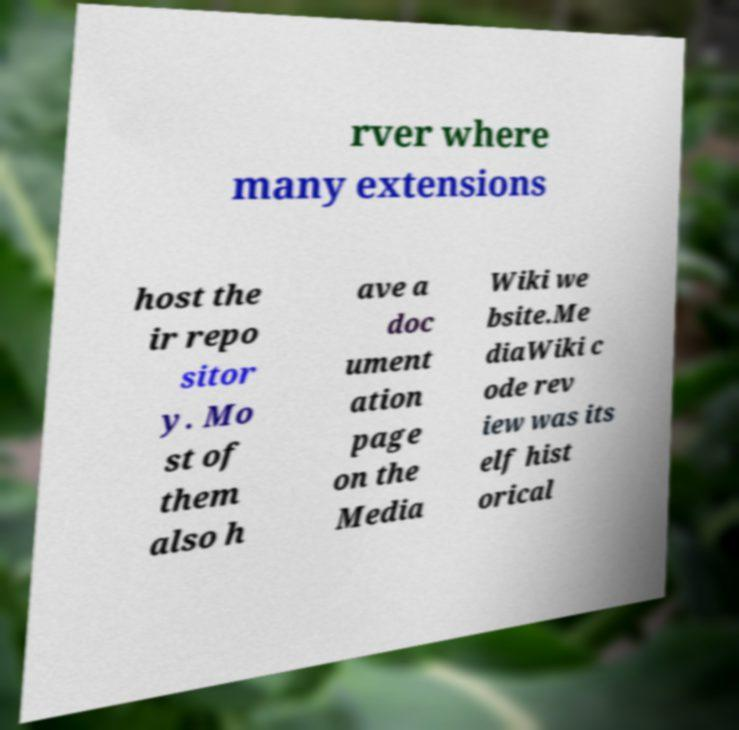For documentation purposes, I need the text within this image transcribed. Could you provide that? rver where many extensions host the ir repo sitor y. Mo st of them also h ave a doc ument ation page on the Media Wiki we bsite.Me diaWiki c ode rev iew was its elf hist orical 